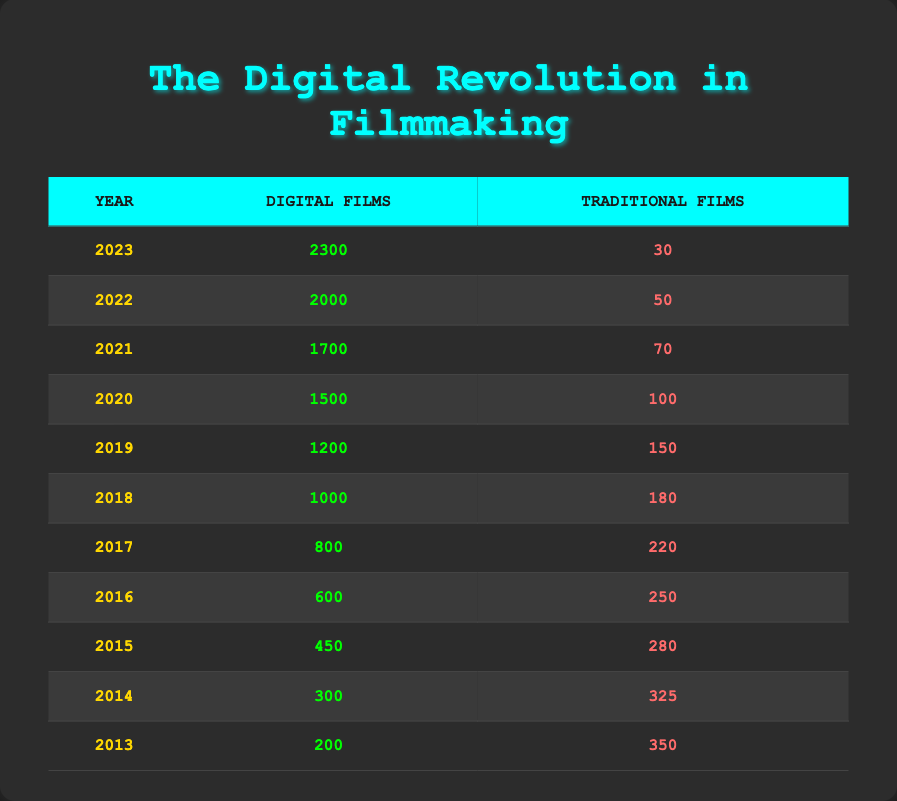What was the total number of films released in 2023? In 2023, the table shows 2300 digital films and 30 traditional films. Adding these together gives a total of 2300 + 30 = 2330.
Answer: 2330 How many traditional films were released in 2015? The table clearly states that 280 traditional films were released in 2015.
Answer: 280 What is the difference in the number of digital films between 2022 and 2023? In 2023, there were 2300 digital films, and in 2022, there were 2000. The difference is 2300 - 2000 = 300.
Answer: 300 What is the average number of traditional films released over the last decade? To find the average, sum the traditional films from 2013-2023 which totals 350 + 325 + 280 + 250 + 220 + 180 + 150 + 100 + 70 + 50 + 30 = 2055. There are 11 years, so the average is 2055 / 11 ≈ 186.82.
Answer: Approximately 186.82 In which year were the fewest traditional films produced? Looking at the table, the year with the least number of traditional films is 2023 with 30 films.
Answer: 2023 How many digital films were released in 2016 compared to 2014? According to the table, 2016 had 600 digital films and 2014 had 300. The difference between these years is 600 - 300 = 300 more digital films in 2016.
Answer: 300 Did the number of digital films ever fall below 200 in any year? The lowest number of digital films released was 200 in 2013. Since it did not fall below this number, the answer is no.
Answer: No What was the trend in the digital film releases from 2013 to 2023? The digital films increased each year from 200 in 2013 to 2300 in 2023, indicating a consistent upward trend.
Answer: Upward trend By how much did digital film releases increase from 2017 to 2018? In 2018, there were 1000 digital films, and in 2017 there were 800. The increase is 1000 - 800 = 200.
Answer: 200 What percentage of all films were digital in 2020? In 2020, the total films were 1500 digital and 100 traditional; the total is 1500 + 100 = 1600. The percentage of digital films is (1500/1600) * 100 = 93.75%.
Answer: 93.75% 